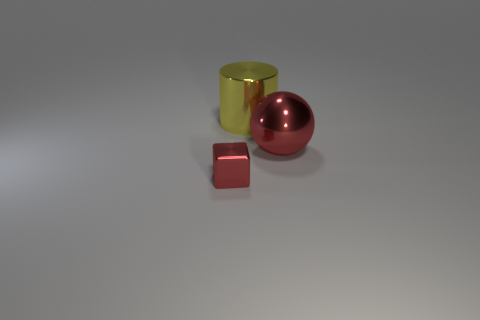The large metallic sphere is what color?
Offer a terse response. Red. Is there anything else of the same color as the cylinder?
Keep it short and to the point. No. What number of other objects are there of the same size as the ball?
Your answer should be very brief. 1. There is a thing right of the large thing behind the large thing right of the big cylinder; what is it made of?
Ensure brevity in your answer.  Metal. Is the yellow cylinder made of the same material as the big thing that is on the right side of the yellow thing?
Provide a short and direct response. Yes. Are there fewer red spheres that are right of the big red metal thing than yellow metal cylinders that are in front of the small thing?
Your answer should be very brief. No. How many big yellow cylinders have the same material as the tiny red object?
Offer a very short reply. 1. There is a object that is in front of the red shiny thing that is on the right side of the yellow thing; is there a small thing left of it?
Offer a very short reply. No. How many blocks are either big yellow shiny things or large gray matte things?
Offer a terse response. 0. Do the big yellow shiny object and the shiny thing that is to the right of the large yellow shiny cylinder have the same shape?
Offer a very short reply. No. 